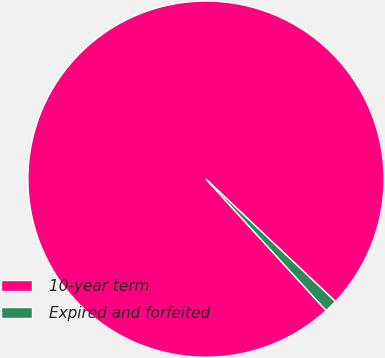<chart> <loc_0><loc_0><loc_500><loc_500><pie_chart><fcel>10-year term<fcel>Expired and forfeited<nl><fcel>98.84%<fcel>1.16%<nl></chart> 